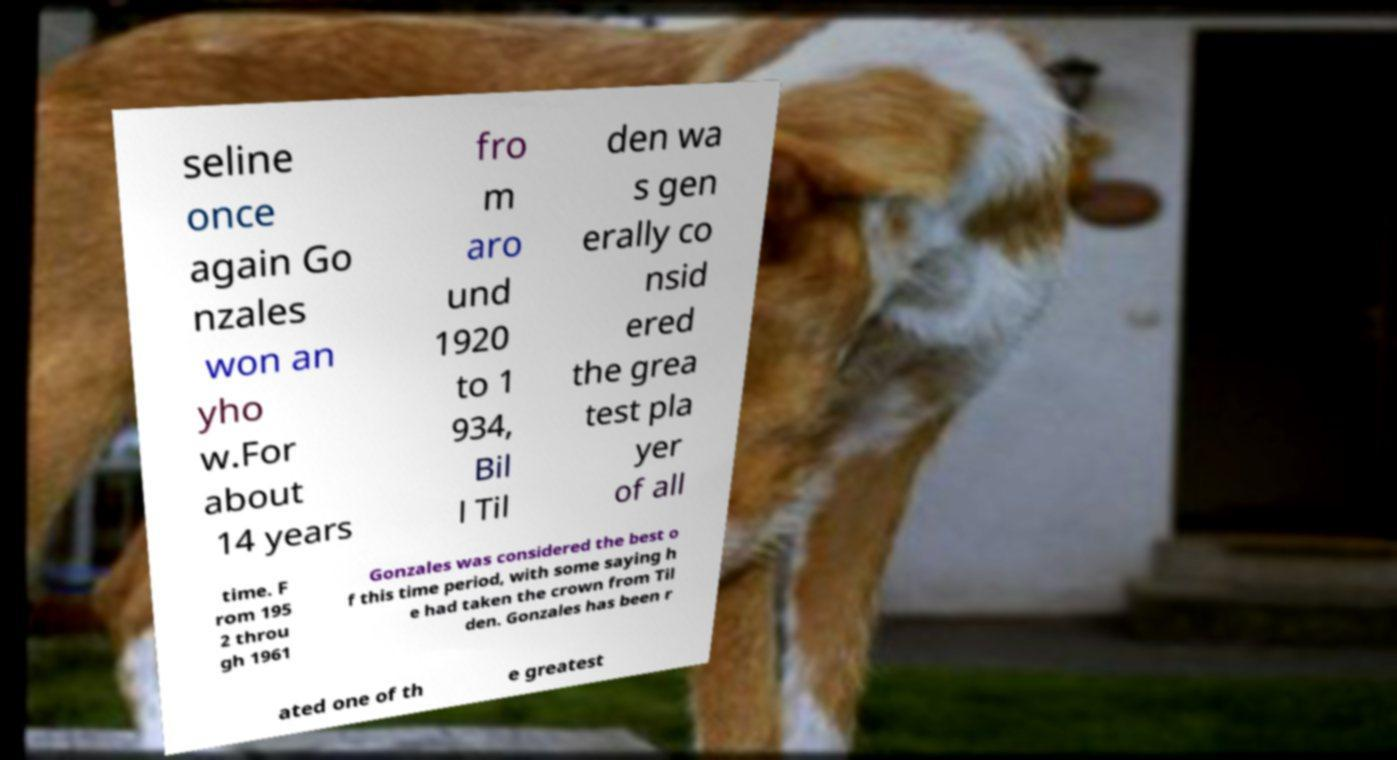Can you read and provide the text displayed in the image?This photo seems to have some interesting text. Can you extract and type it out for me? seline once again Go nzales won an yho w.For about 14 years fro m aro und 1920 to 1 934, Bil l Til den wa s gen erally co nsid ered the grea test pla yer of all time. F rom 195 2 throu gh 1961 Gonzales was considered the best o f this time period, with some saying h e had taken the crown from Til den. Gonzales has been r ated one of th e greatest 